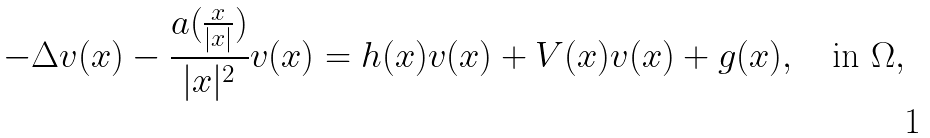<formula> <loc_0><loc_0><loc_500><loc_500>- \Delta v ( x ) - \frac { a ( \frac { x } { | x | } ) } { | x | ^ { 2 } } v ( x ) = h ( x ) v ( x ) + V ( x ) v ( x ) + g ( x ) , \quad \text {in } \Omega ,</formula> 